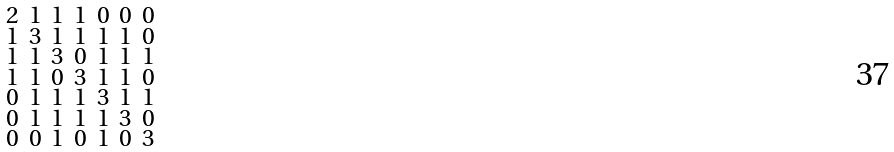Convert formula to latex. <formula><loc_0><loc_0><loc_500><loc_500>\begin{smallmatrix} 2 & 1 & 1 & 1 & 0 & 0 & 0 \\ 1 & 3 & 1 & 1 & 1 & 1 & 0 \\ 1 & 1 & 3 & 0 & 1 & 1 & 1 \\ 1 & 1 & 0 & 3 & 1 & 1 & 0 \\ 0 & 1 & 1 & 1 & 3 & 1 & 1 \\ 0 & 1 & 1 & 1 & 1 & 3 & 0 \\ 0 & 0 & 1 & 0 & 1 & 0 & 3 \end{smallmatrix}</formula> 